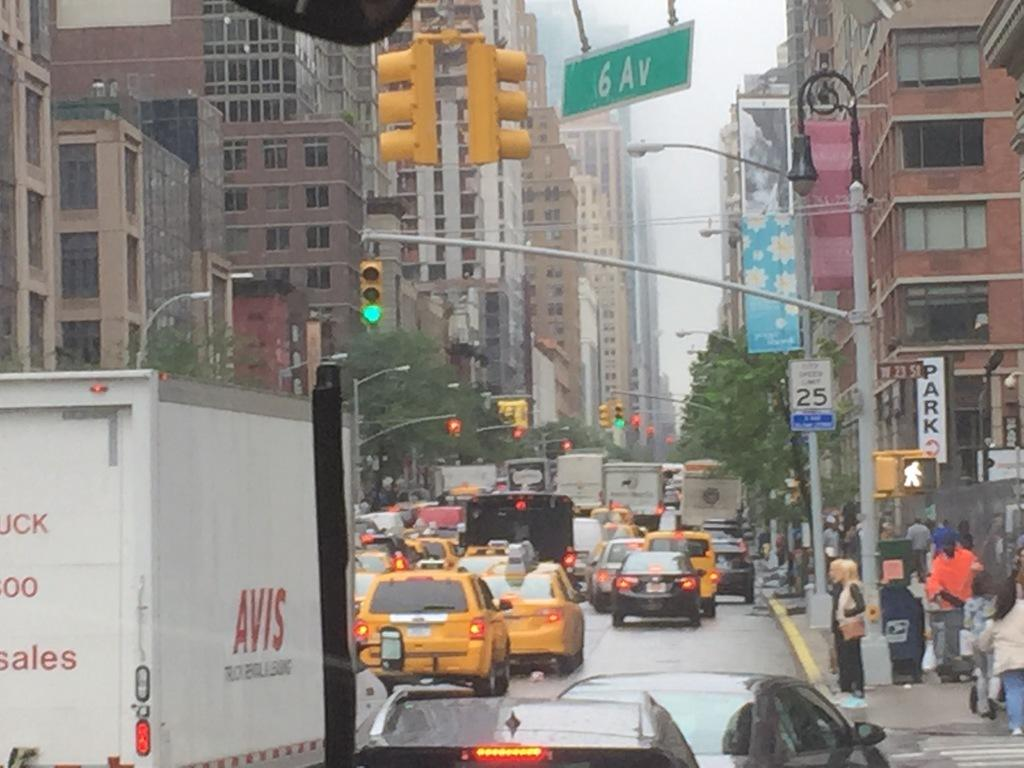<image>
Present a compact description of the photo's key features. AN AVIS TRUCK AND TAXIS DRIVING DOWN SIXTH AVE 